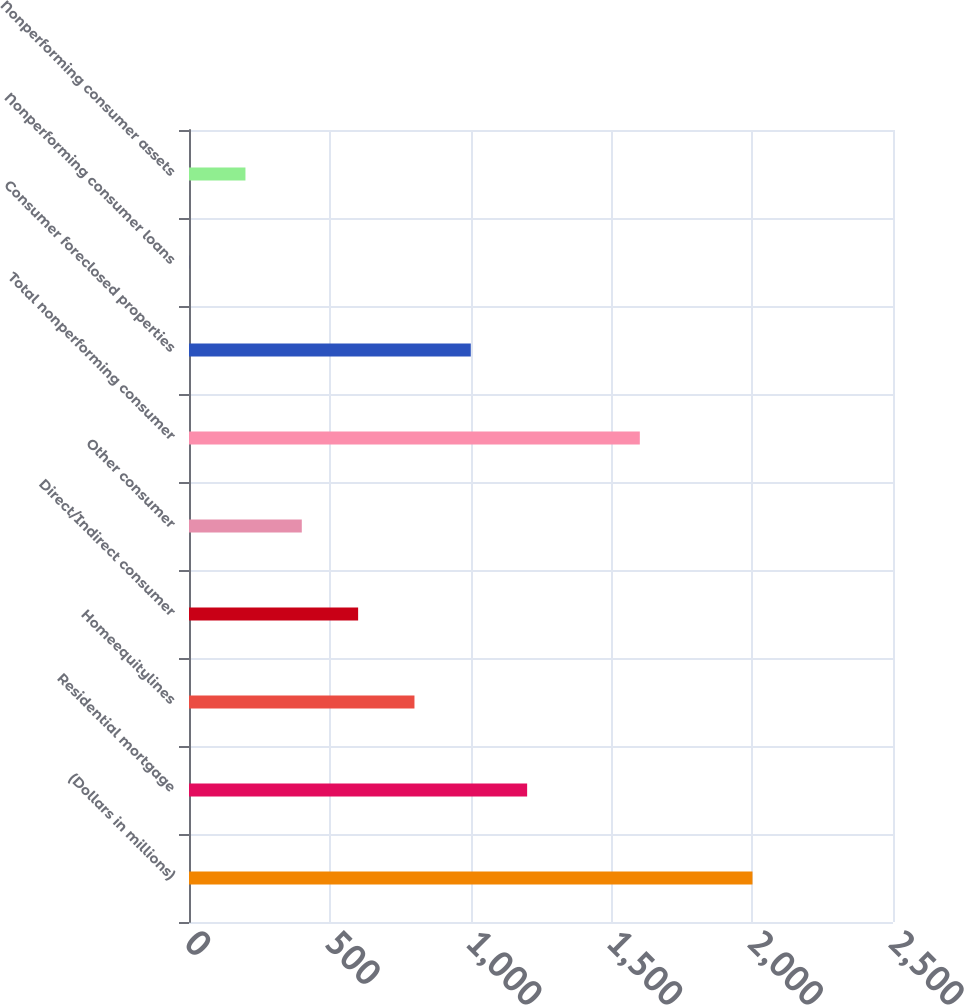Convert chart. <chart><loc_0><loc_0><loc_500><loc_500><bar_chart><fcel>(Dollars in millions)<fcel>Residential mortgage<fcel>Homeequitylines<fcel>Direct/Indirect consumer<fcel>Other consumer<fcel>Total nonperforming consumer<fcel>Consumer foreclosed properties<fcel>Nonperforming consumer loans<fcel>Nonperforming consumer assets<nl><fcel>2001<fcel>1200.77<fcel>800.65<fcel>600.59<fcel>400.53<fcel>1600.89<fcel>1000.71<fcel>0.41<fcel>200.47<nl></chart> 